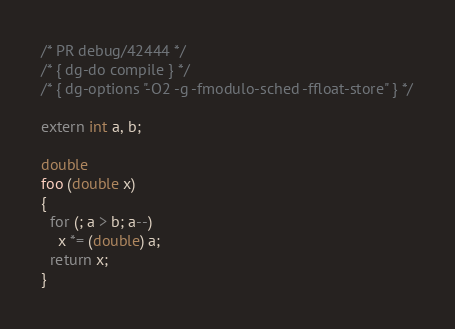<code> <loc_0><loc_0><loc_500><loc_500><_C_>/* PR debug/42444 */
/* { dg-do compile } */
/* { dg-options "-O2 -g -fmodulo-sched -ffloat-store" } */

extern int a, b;

double
foo (double x)
{
  for (; a > b; a--)
    x *= (double) a;
  return x;
}
</code> 